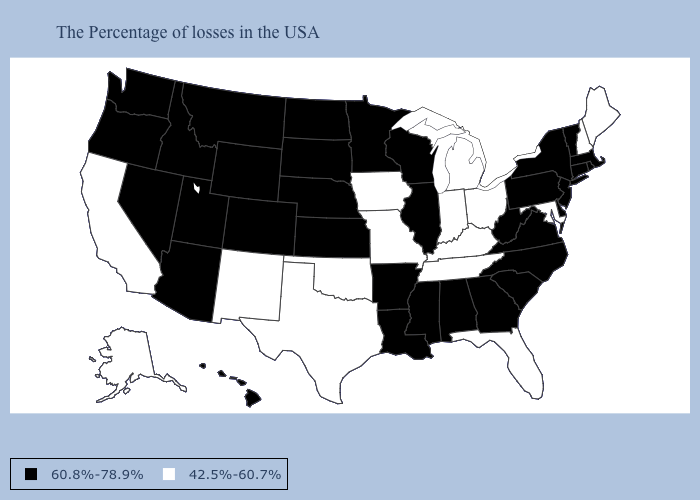Among the states that border California , which have the lowest value?
Concise answer only. Arizona, Nevada, Oregon. Does New York have the highest value in the Northeast?
Give a very brief answer. Yes. Does Rhode Island have a lower value than Hawaii?
Write a very short answer. No. Name the states that have a value in the range 60.8%-78.9%?
Answer briefly. Massachusetts, Rhode Island, Vermont, Connecticut, New York, New Jersey, Delaware, Pennsylvania, Virginia, North Carolina, South Carolina, West Virginia, Georgia, Alabama, Wisconsin, Illinois, Mississippi, Louisiana, Arkansas, Minnesota, Kansas, Nebraska, South Dakota, North Dakota, Wyoming, Colorado, Utah, Montana, Arizona, Idaho, Nevada, Washington, Oregon, Hawaii. What is the lowest value in the USA?
Write a very short answer. 42.5%-60.7%. Does South Dakota have the lowest value in the USA?
Write a very short answer. No. Is the legend a continuous bar?
Write a very short answer. No. How many symbols are there in the legend?
Write a very short answer. 2. Name the states that have a value in the range 60.8%-78.9%?
Give a very brief answer. Massachusetts, Rhode Island, Vermont, Connecticut, New York, New Jersey, Delaware, Pennsylvania, Virginia, North Carolina, South Carolina, West Virginia, Georgia, Alabama, Wisconsin, Illinois, Mississippi, Louisiana, Arkansas, Minnesota, Kansas, Nebraska, South Dakota, North Dakota, Wyoming, Colorado, Utah, Montana, Arizona, Idaho, Nevada, Washington, Oregon, Hawaii. Does Illinois have the same value as Kentucky?
Answer briefly. No. What is the value of Tennessee?
Answer briefly. 42.5%-60.7%. Among the states that border Indiana , does Illinois have the highest value?
Concise answer only. Yes. What is the value of Georgia?
Concise answer only. 60.8%-78.9%. What is the value of Louisiana?
Quick response, please. 60.8%-78.9%. 